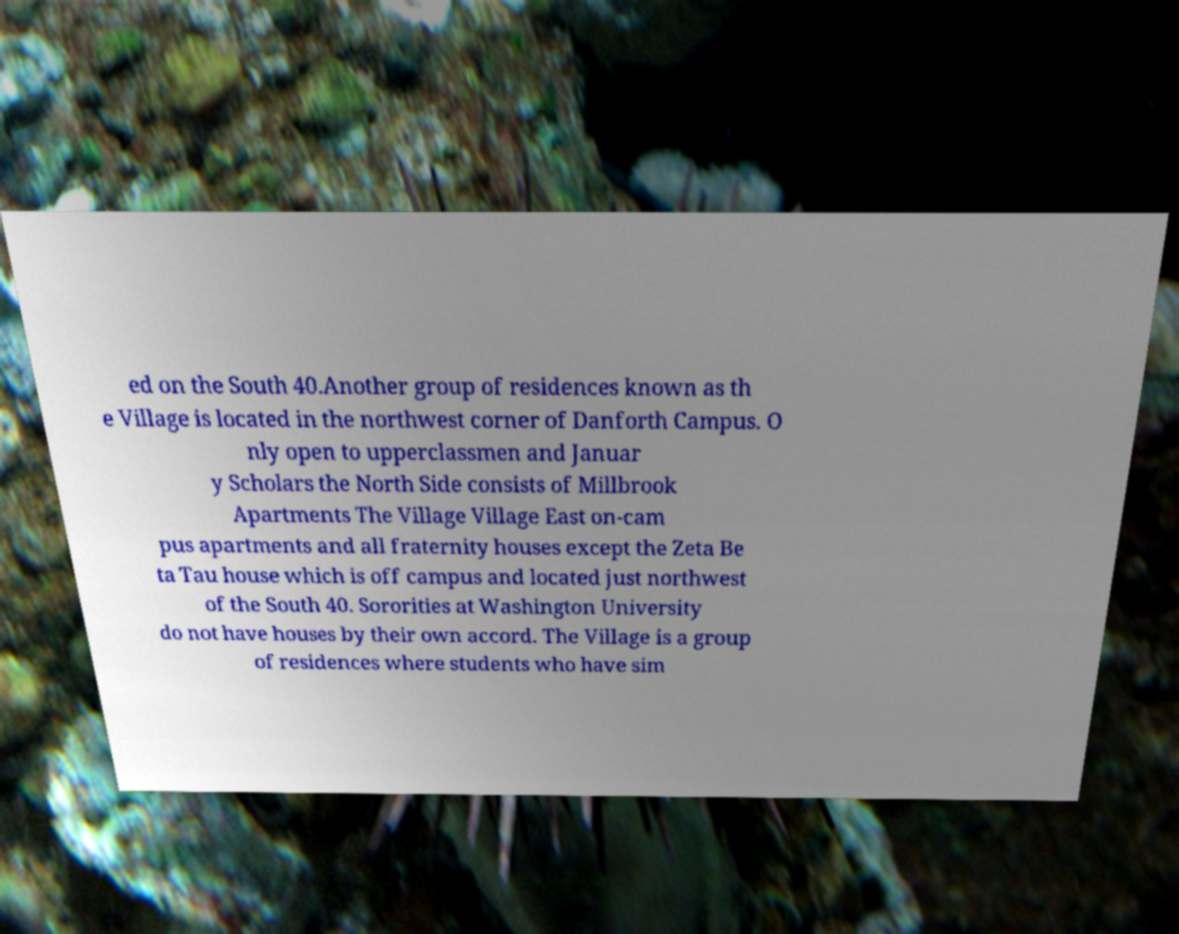Please read and relay the text visible in this image. What does it say? ed on the South 40.Another group of residences known as th e Village is located in the northwest corner of Danforth Campus. O nly open to upperclassmen and Januar y Scholars the North Side consists of Millbrook Apartments The Village Village East on-cam pus apartments and all fraternity houses except the Zeta Be ta Tau house which is off campus and located just northwest of the South 40. Sororities at Washington University do not have houses by their own accord. The Village is a group of residences where students who have sim 